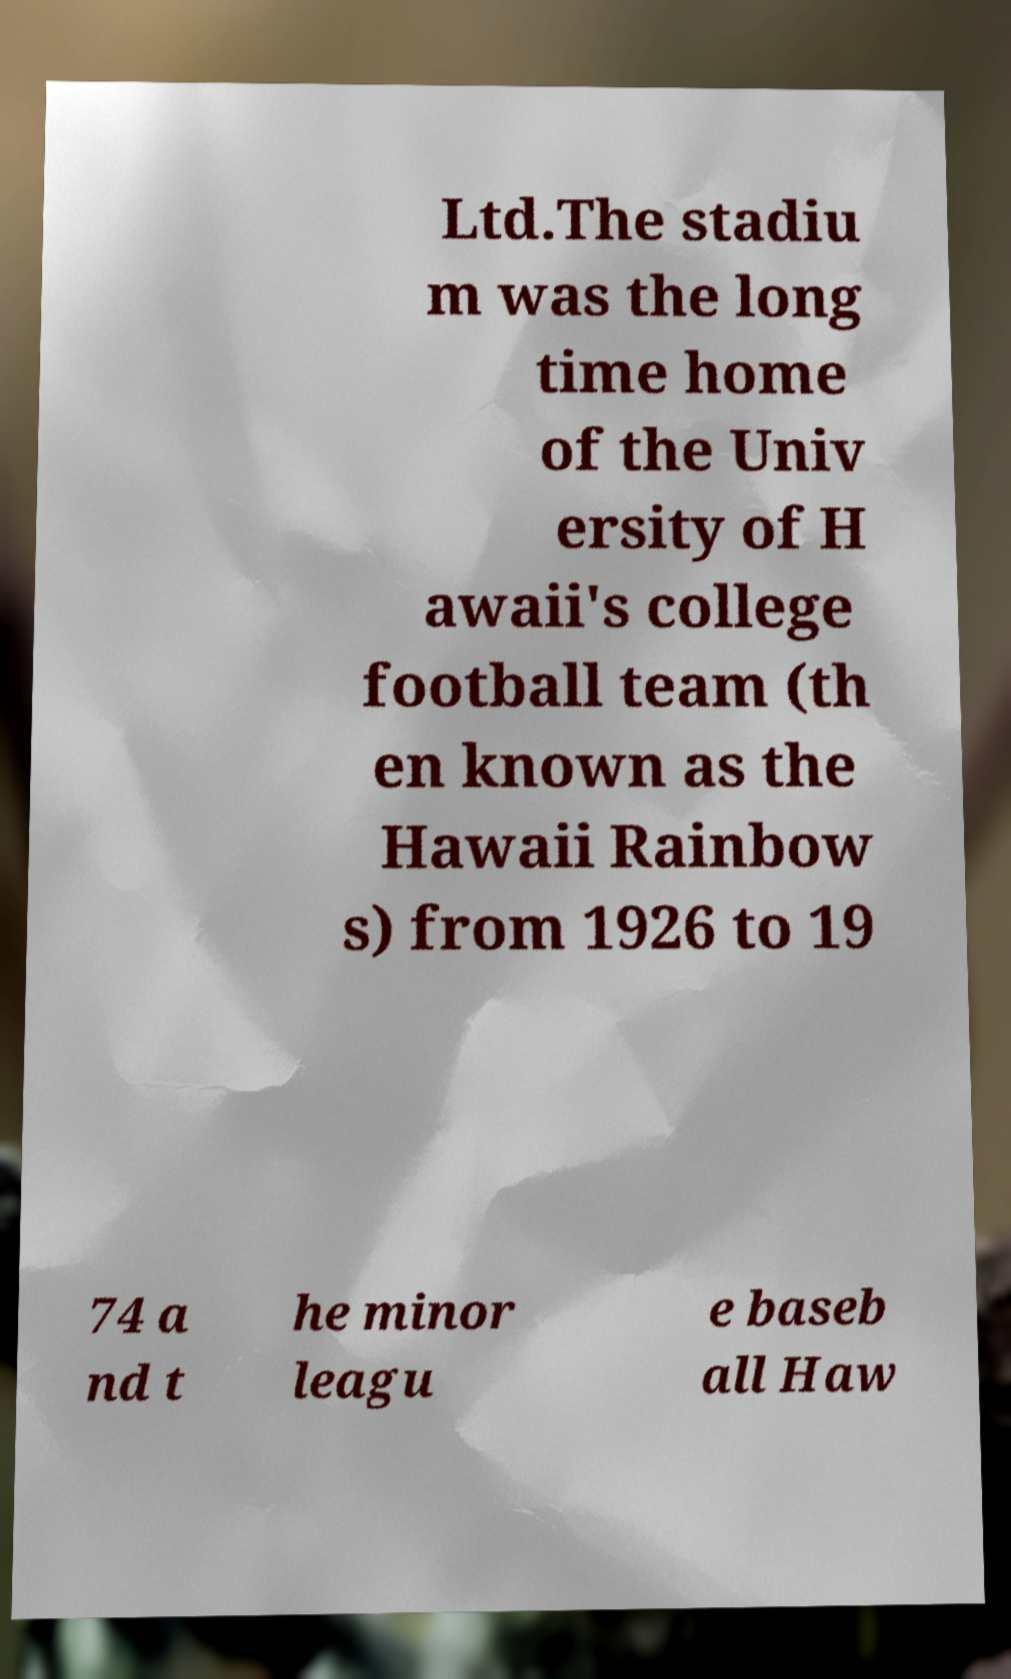For documentation purposes, I need the text within this image transcribed. Could you provide that? Ltd.The stadiu m was the long time home of the Univ ersity of H awaii's college football team (th en known as the Hawaii Rainbow s) from 1926 to 19 74 a nd t he minor leagu e baseb all Haw 